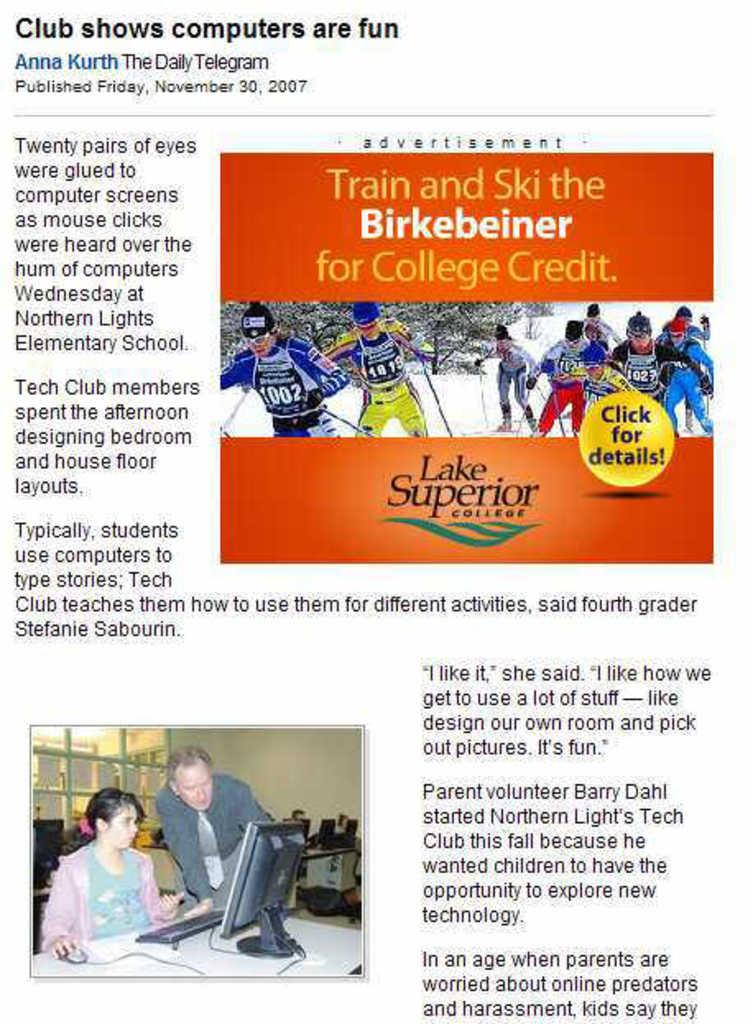What type of visual is the image in question? The image appears to be a poster. What can be seen on the poster? There are images of people on the poster. Are there any words or phrases on the poster? Yes, there is text written on the poster. What type of vegetable is being played by the band in the poster? There is no band or vegetable present in the poster; it features images of people and text. 